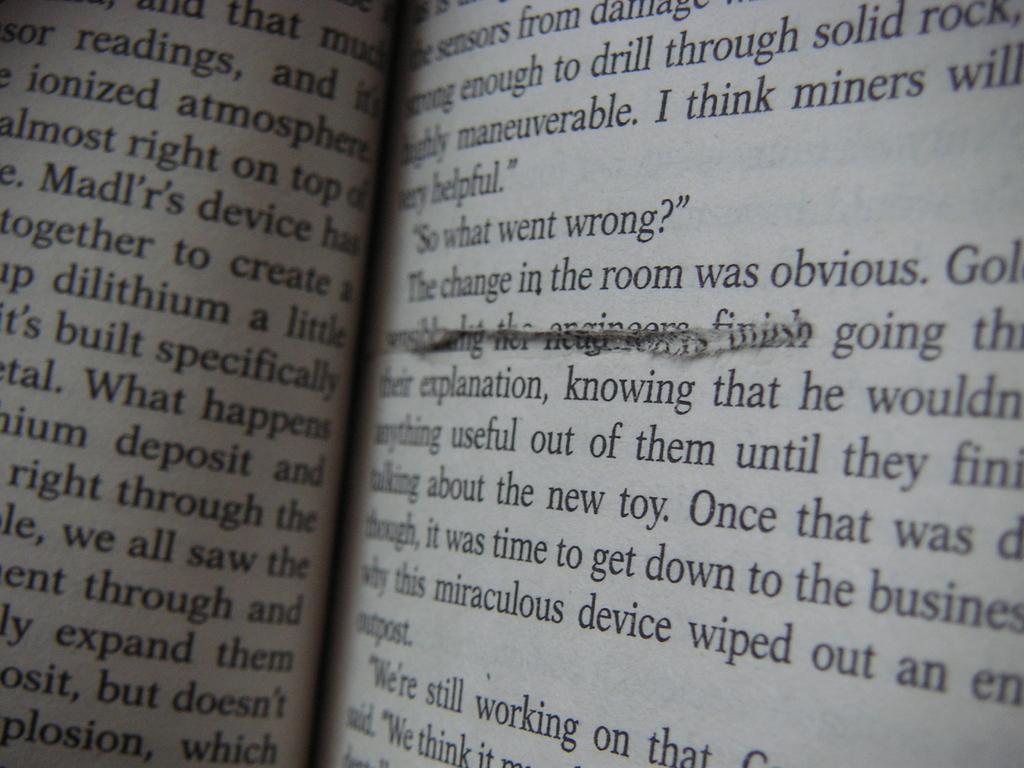Was the change in the room obvious?
Ensure brevity in your answer.  Yes. 